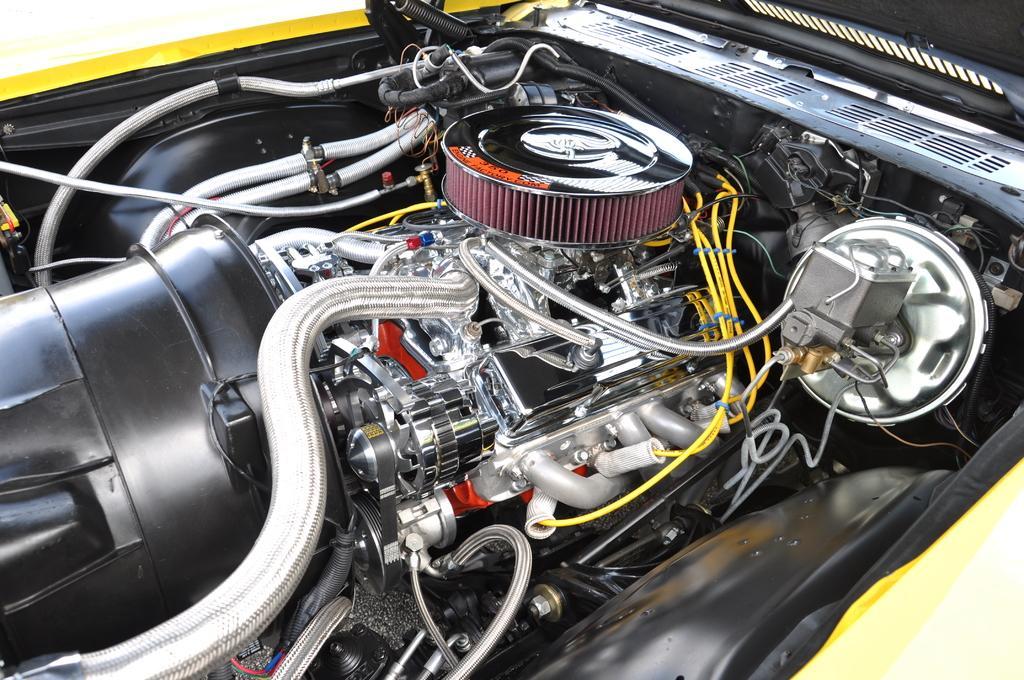In one or two sentences, can you explain what this image depicts? In this image, we can see internal parts of a vehicle. 